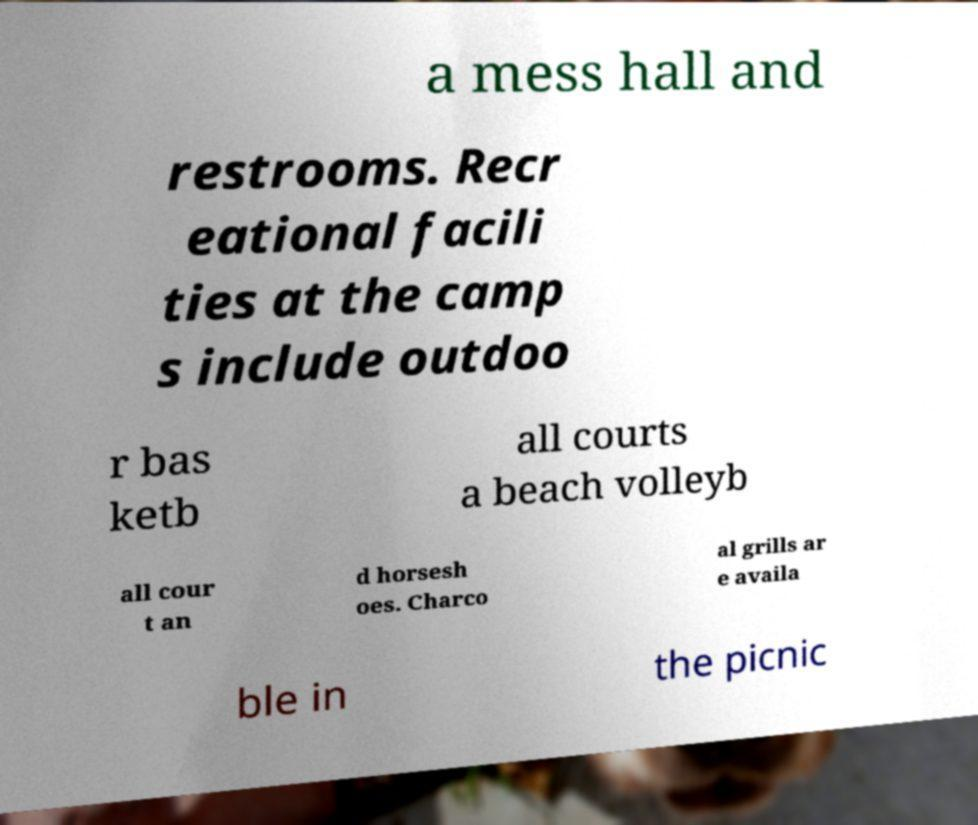Could you assist in decoding the text presented in this image and type it out clearly? a mess hall and restrooms. Recr eational facili ties at the camp s include outdoo r bas ketb all courts a beach volleyb all cour t an d horsesh oes. Charco al grills ar e availa ble in the picnic 